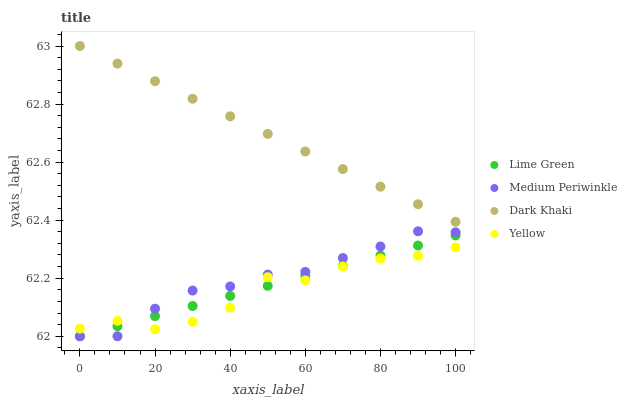Does Yellow have the minimum area under the curve?
Answer yes or no. Yes. Does Dark Khaki have the maximum area under the curve?
Answer yes or no. Yes. Does Medium Periwinkle have the minimum area under the curve?
Answer yes or no. No. Does Medium Periwinkle have the maximum area under the curve?
Answer yes or no. No. Is Lime Green the smoothest?
Answer yes or no. Yes. Is Yellow the roughest?
Answer yes or no. Yes. Is Medium Periwinkle the smoothest?
Answer yes or no. No. Is Medium Periwinkle the roughest?
Answer yes or no. No. Does Medium Periwinkle have the lowest value?
Answer yes or no. Yes. Does Yellow have the lowest value?
Answer yes or no. No. Does Dark Khaki have the highest value?
Answer yes or no. Yes. Does Medium Periwinkle have the highest value?
Answer yes or no. No. Is Medium Periwinkle less than Dark Khaki?
Answer yes or no. Yes. Is Dark Khaki greater than Yellow?
Answer yes or no. Yes. Does Lime Green intersect Yellow?
Answer yes or no. Yes. Is Lime Green less than Yellow?
Answer yes or no. No. Is Lime Green greater than Yellow?
Answer yes or no. No. Does Medium Periwinkle intersect Dark Khaki?
Answer yes or no. No. 